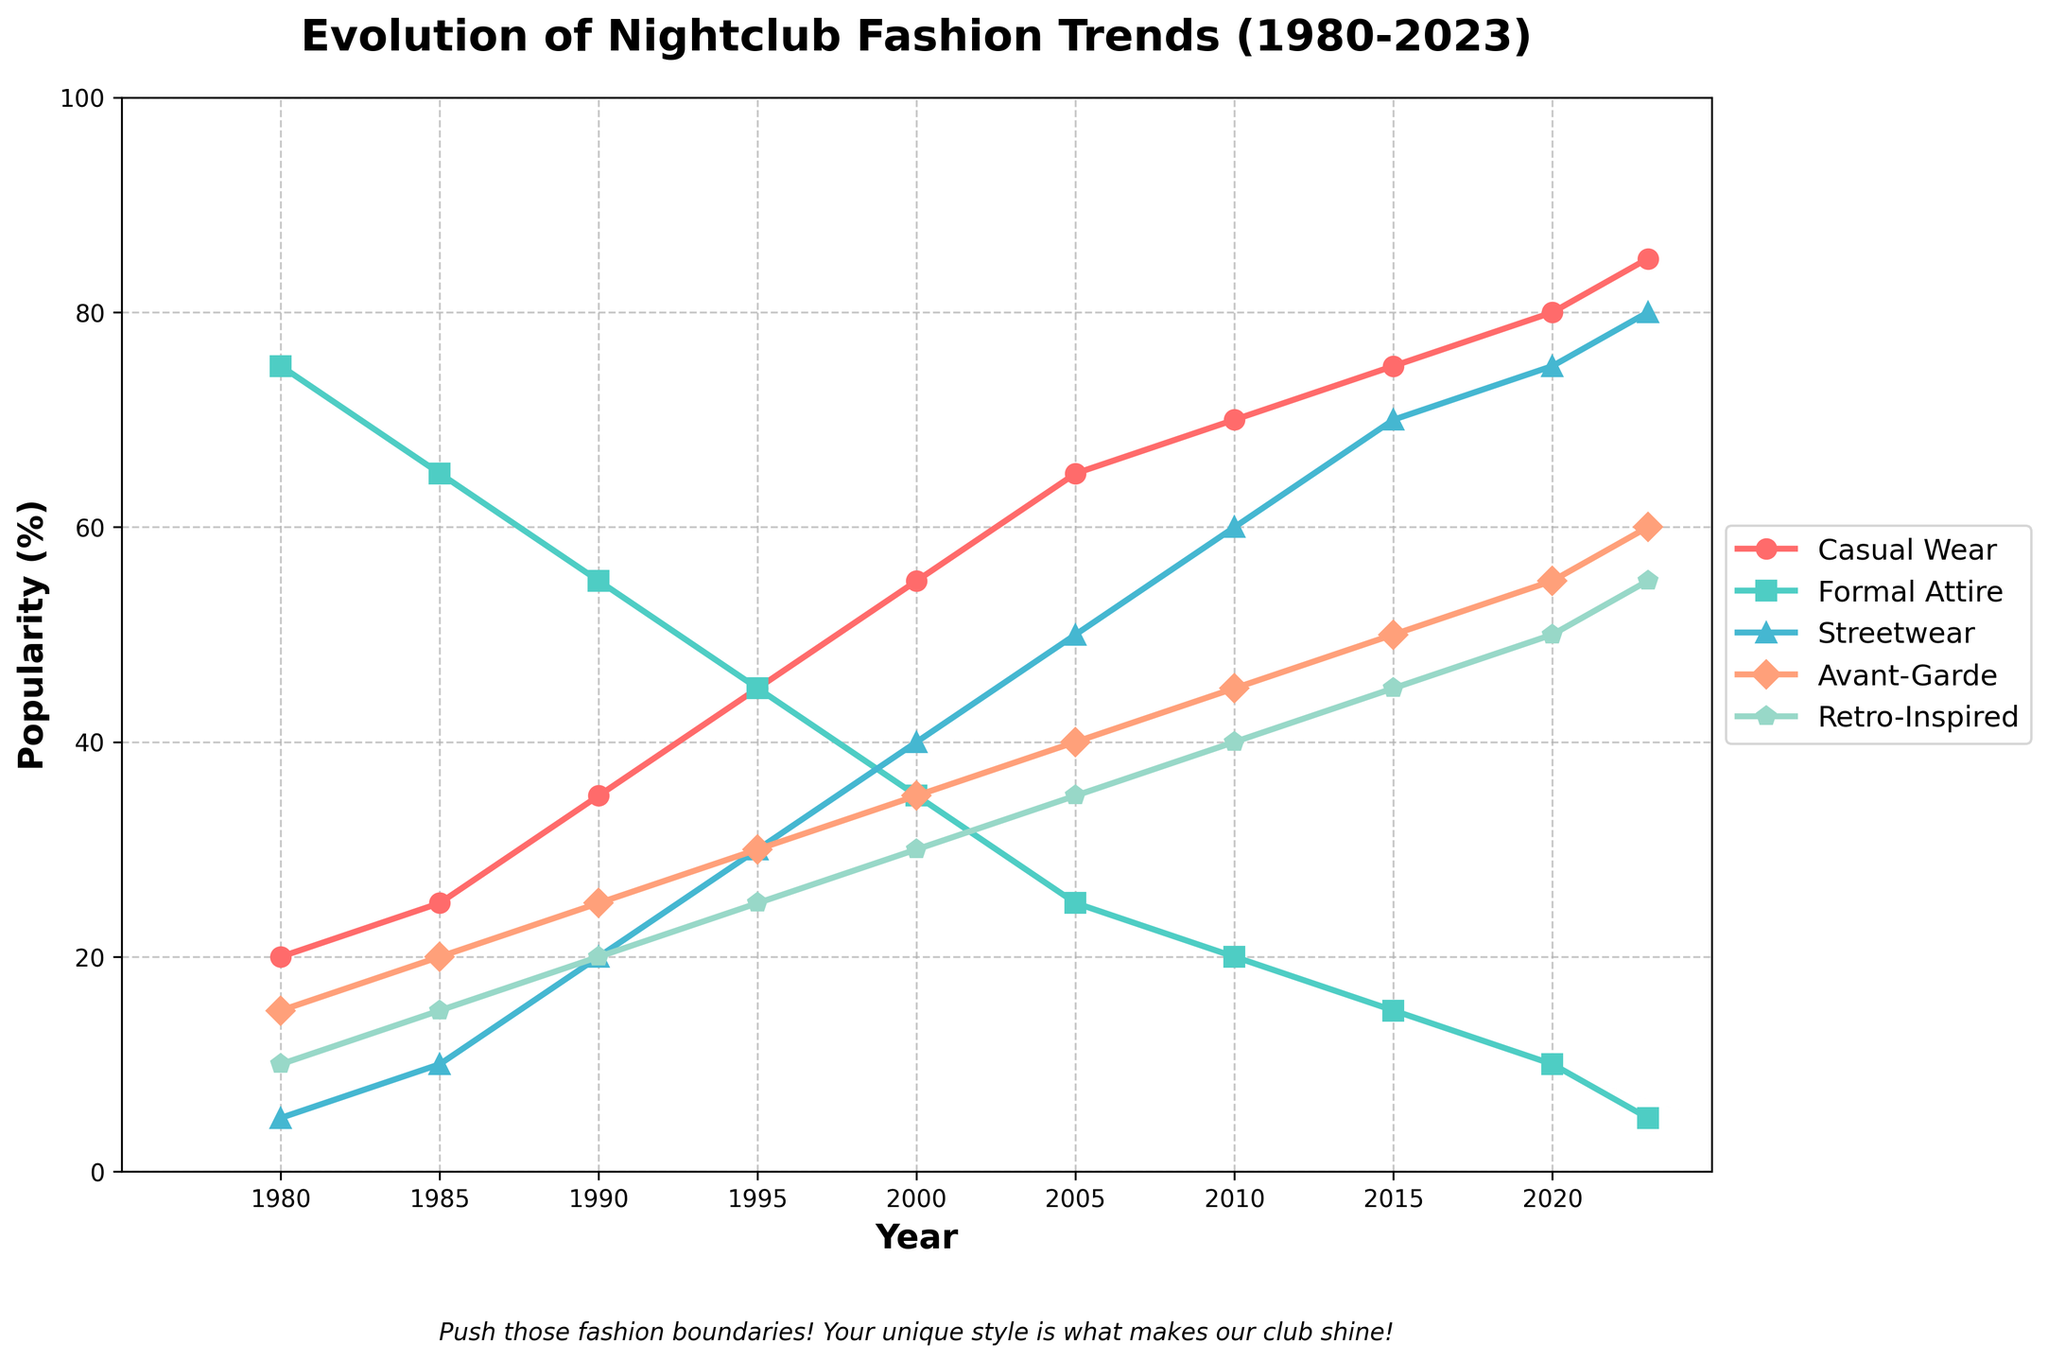Which fashion category saw the biggest increase in popularity between 1980 and 2023? To find the biggest increase, compare percentages for each category between 1980 and 2023. Casual Wear increased from 20% to 85%, a rise of 65%. Formal Attire decreased, so it's out. Streetwear went from 5% to 80%, a 75% increase. Avant-Garde moved from 15% to 60%, an increase of 45%. Retro-Inspired went from 10% to 55%, an increase of 45%. Therefore, Streetwear had the biggest increase of 75%.
Answer: Streetwear How much did the popularity of Formal Attire decrease from 1980 to 2023? Check the values for Formal Attire in 1980 and 2023. In 1980, it was 75%; in 2023, it's 5%. The decrease is 75% - 5% = 70%.
Answer: 70% Which year did Casual Wear first surpass Formal Attire in popularity? Look for the first crossover point where Casual Wear’s percentage surpasses that of Formal Attire. This happens around 1995 where Casual Wear is 45% and Formal Attire is also 45%. The next year, Casual Wear further increases, solidifying the first surpass in 1995.
Answer: 1995 During which decade did Avant-Garde fashion see its highest growth rate? Evaluate the change in Avant-Garde fashion by each decade. From 1980-1990 it grew from 15% to 25% (+10%); from 1990-2000 it grew to 35% (+10%); from 2000-2010 it grew to 45% (+10%); from 2010-2023 it grew to 60% (+15%). Thus, it saw its highest growth rate from 2010 to 2023.
Answer: 2010-2023 What was the ratio of popularity between Retro-Inspired and Streetwear fashion in 2000? Check the popularity percentages for Retro-Inspired and Streetwear in 2000. Retro-Inspired is at 30% and Streetwear is at 40%. The ratio is 30:40, simplifying down to 3:4.
Answer: 3:4 How did the total combined popularity of Formal Attire and Avant-Garde trends change from 1990 to 2005? Add the percentages of Formal Attire and Avant-Garde for both years. In 1990, Formal Attire is 55% and Avant-Garde is 25% (55 + 25 = 80%). In 2005, Formal Attire is 25% and Avant-Garde is 40% (25 + 40 = 65%). The change is 80% - 65% = 15%.
Answer: Decreased by 15% In the year 2015, how did the popularity of Streetwear compare to the combination of Casual Wear and Retro-Inspired? Check the percentages for Streetwear, Casual Wear, and Retro-Inspired in 2015. Streetwear: 70%; Casual Wear: 75%; Retro-Inspired: 45%. The combined popularity of Casual Wear and Retro-Inspired is 75 + 45 = 120%. Streetwear’s 70% is less than the combined 120%.
Answer: Less than What is the average popularity of Avant-Garde fashion over the entire period? Sum the percentages for Avant-Garde across all the years and divide by the number of years. (15 + 20 + 25 + 30 + 35 + 40 + 45 + 50 + 55 + 60) = 375. There are 10 data points, so the average is 375 / 10 = 37.5%.
Answer: 37.5% Between which two consecutive years did Streetwear see the highest jump in popularity? Compare the year-by-year differences in Streetwear's popularity. Differences: 1980-1985: 5%, 1985-1990: 10%, 1990-1995: 10%, 1995-2000: 10%, 2000-2005: 10%, 2005-2010: 10%, 2010-2015: 10%, 2015-2020: 5%, 2020-2023: 5%. The highest jump is 10%, which occurs multiple times (1985-1990, 1990-1995, 1995-2000, 2000-2005, 2005-2010, 2010-2015).
Answer: 1985-1990 (also acceptable are other periods with the same increase) 